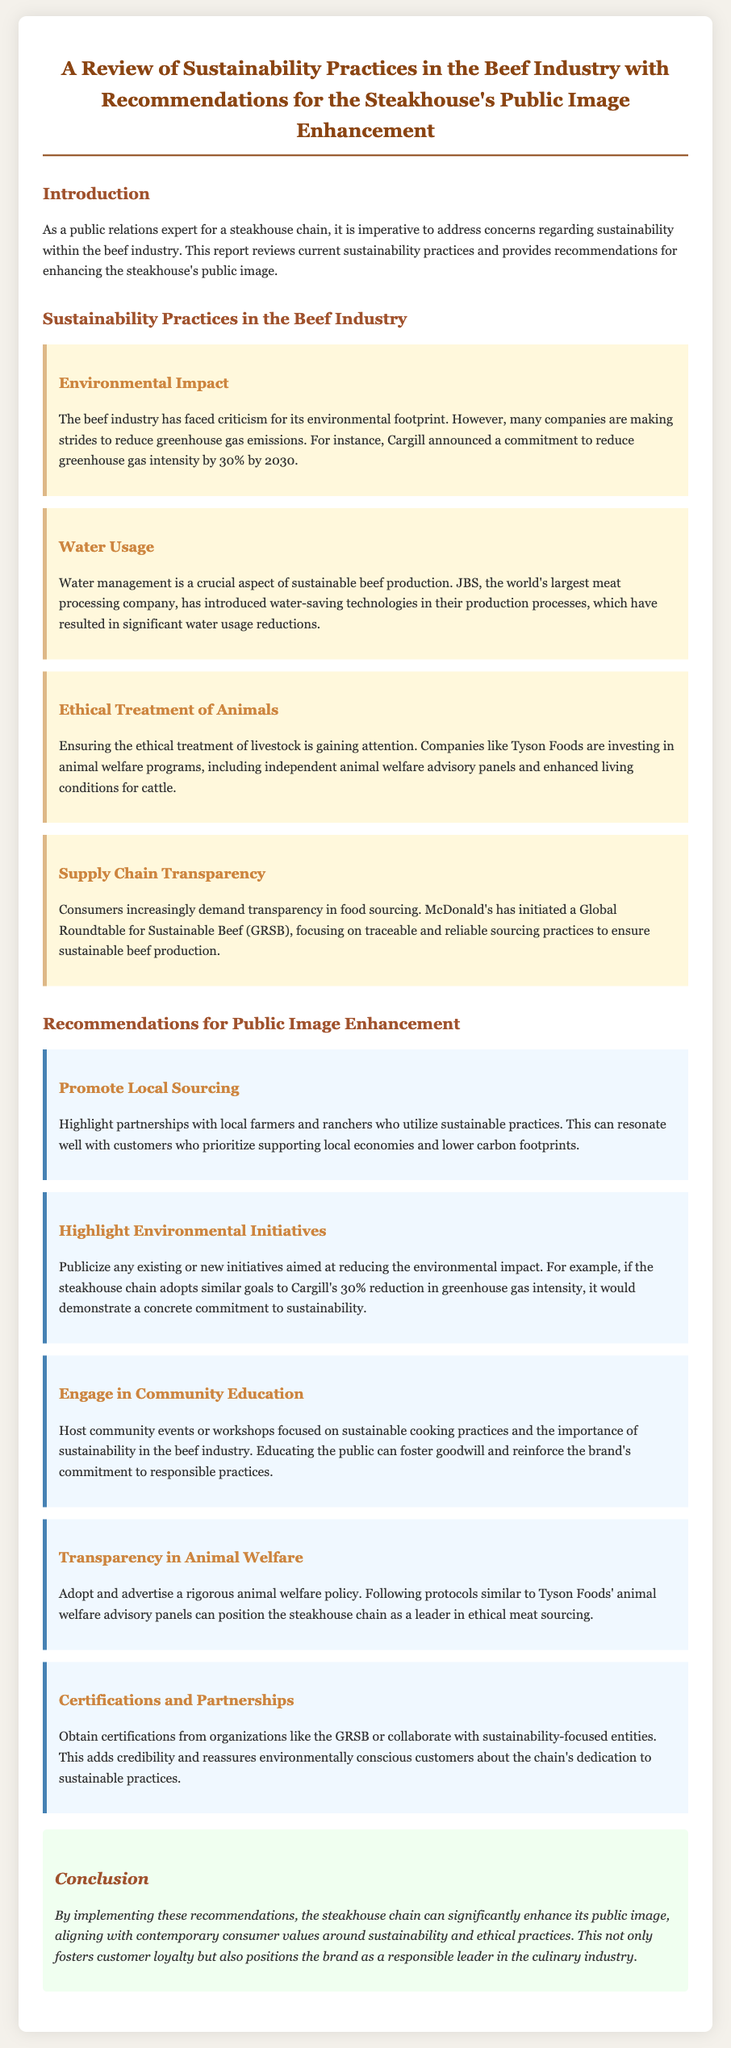what is the title of the document? The title is explicitly stated at the top of the document as "A Review of Sustainability Practices in the Beef Industry with Recommendations for the Steakhouse's Public Image Enhancement."
Answer: A Review of Sustainability Practices in the Beef Industry with Recommendations for the Steakhouse's Public Image Enhancement who announced a commitment to reduce greenhouse gas intensity? The document states that Cargill announced a commitment to reduce greenhouse gas intensity by 30% by 2030.
Answer: Cargill what company has introduced water-saving technologies? The document mentions that JBS has introduced water-saving technologies in their production processes.
Answer: JBS what is one recommendation for enhancing the public image? The document provides several recommendations, one of which is to "Promote Local Sourcing."
Answer: Promote Local Sourcing which organization is mentioned in relation to supply chain transparency? The document notes that McDonald's has initiated a Global Roundtable for Sustainable Beef (GRSB) focusing on traceable and reliable sourcing practices.
Answer: Global Roundtable for Sustainable Beef (GRSB) what initiative can foster goodwill in the community? The document recommends hosting community events or workshops focused on sustainable cooking practices as an initiative to foster goodwill.
Answer: Host community events or workshops what is the color of the section titles? The section titles are colored in different shades; the main titles are colored in "A0522D," which is a shade of brown.
Answer: A0522D how much reduction in greenhouse gas intensity has Cargill committed to by 2030? The document specifies that Cargill has committed to a 30% reduction in greenhouse gas intensity by 2030.
Answer: 30% what type of document is this? This document presents a review and recommendations, characteristic of a homework assignment or report, specifically addressing sustainability practices.
Answer: Homework 